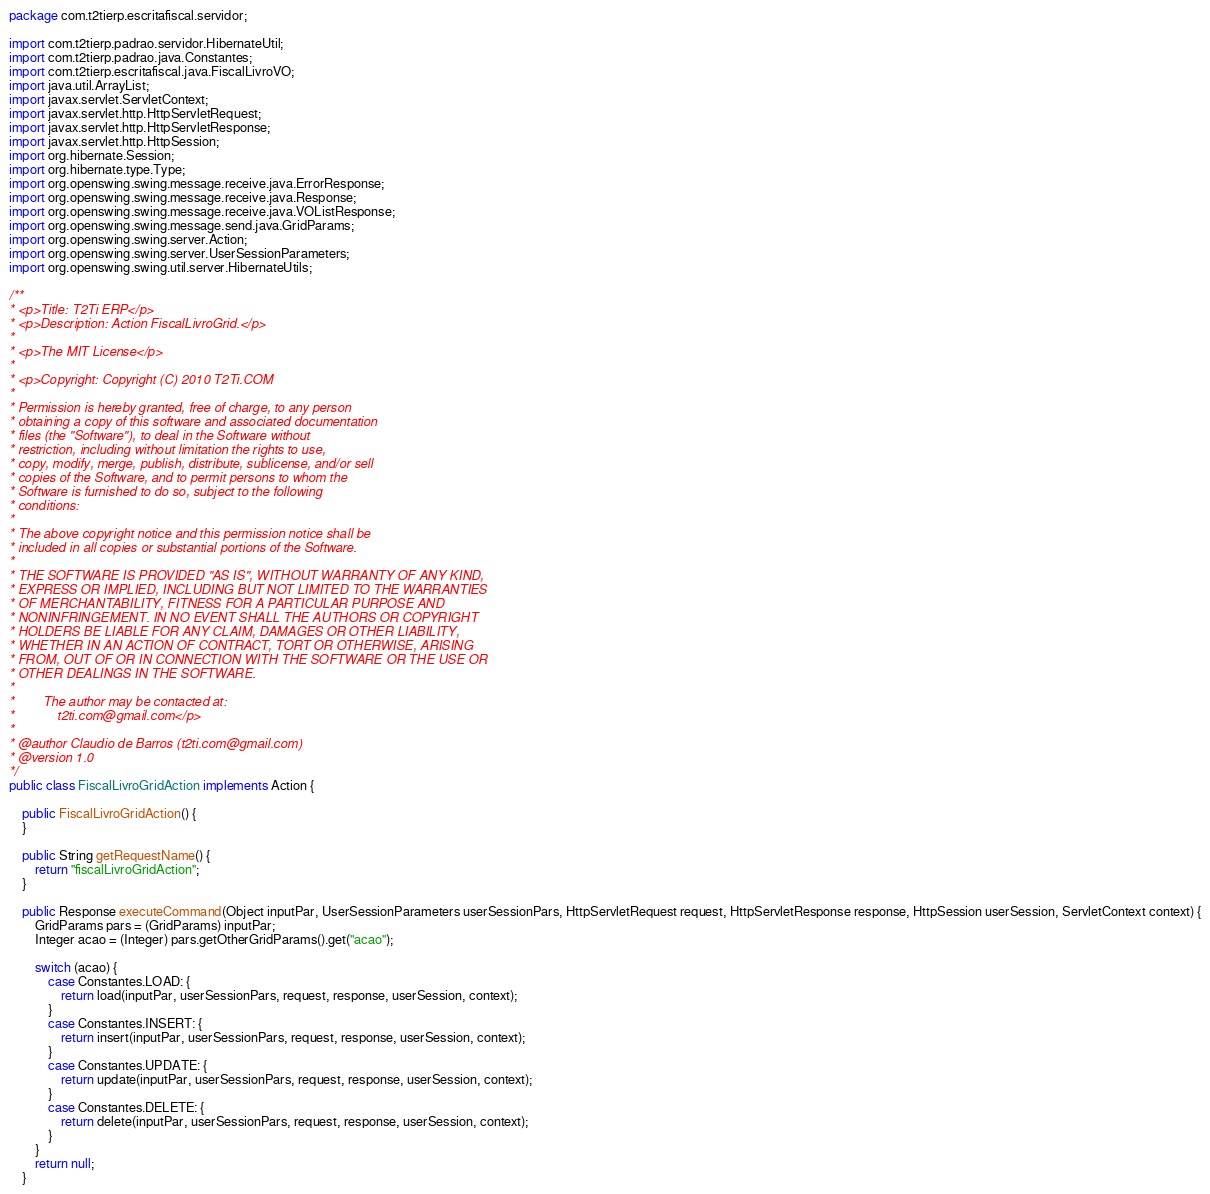<code> <loc_0><loc_0><loc_500><loc_500><_Java_>package com.t2tierp.escritafiscal.servidor;

import com.t2tierp.padrao.servidor.HibernateUtil;
import com.t2tierp.padrao.java.Constantes;
import com.t2tierp.escritafiscal.java.FiscalLivroVO;
import java.util.ArrayList;
import javax.servlet.ServletContext;
import javax.servlet.http.HttpServletRequest;
import javax.servlet.http.HttpServletResponse;
import javax.servlet.http.HttpSession;
import org.hibernate.Session;
import org.hibernate.type.Type;
import org.openswing.swing.message.receive.java.ErrorResponse;
import org.openswing.swing.message.receive.java.Response;
import org.openswing.swing.message.receive.java.VOListResponse;
import org.openswing.swing.message.send.java.GridParams;
import org.openswing.swing.server.Action;
import org.openswing.swing.server.UserSessionParameters;
import org.openswing.swing.util.server.HibernateUtils;

/**
* <p>Title: T2Ti ERP</p>
* <p>Description: Action FiscalLivroGrid.</p>
*
* <p>The MIT License</p>
*
* <p>Copyright: Copyright (C) 2010 T2Ti.COM
*
* Permission is hereby granted, free of charge, to any person
* obtaining a copy of this software and associated documentation
* files (the "Software"), to deal in the Software without
* restriction, including without limitation the rights to use,
* copy, modify, merge, publish, distribute, sublicense, and/or sell
* copies of the Software, and to permit persons to whom the
* Software is furnished to do so, subject to the following
* conditions:
*
* The above copyright notice and this permission notice shall be
* included in all copies or substantial portions of the Software.
*
* THE SOFTWARE IS PROVIDED "AS IS", WITHOUT WARRANTY OF ANY KIND,
* EXPRESS OR IMPLIED, INCLUDING BUT NOT LIMITED TO THE WARRANTIES
* OF MERCHANTABILITY, FITNESS FOR A PARTICULAR PURPOSE AND
* NONINFRINGEMENT. IN NO EVENT SHALL THE AUTHORS OR COPYRIGHT
* HOLDERS BE LIABLE FOR ANY CLAIM, DAMAGES OR OTHER LIABILITY,
* WHETHER IN AN ACTION OF CONTRACT, TORT OR OTHERWISE, ARISING
* FROM, OUT OF OR IN CONNECTION WITH THE SOFTWARE OR THE USE OR
* OTHER DEALINGS IN THE SOFTWARE.
*
*        The author may be contacted at:
*            t2ti.com@gmail.com</p>
*
* @author Claudio de Barros (t2ti.com@gmail.com)
* @version 1.0
*/
public class FiscalLivroGridAction implements Action {

    public FiscalLivroGridAction() {
    }

    public String getRequestName() {
        return "fiscalLivroGridAction";
    }

    public Response executeCommand(Object inputPar, UserSessionParameters userSessionPars, HttpServletRequest request, HttpServletResponse response, HttpSession userSession, ServletContext context) {
        GridParams pars = (GridParams) inputPar;
        Integer acao = (Integer) pars.getOtherGridParams().get("acao");

        switch (acao) {
            case Constantes.LOAD: {
                return load(inputPar, userSessionPars, request, response, userSession, context);
            }
            case Constantes.INSERT: {
                return insert(inputPar, userSessionPars, request, response, userSession, context);
            }
            case Constantes.UPDATE: {
                return update(inputPar, userSessionPars, request, response, userSession, context);
            }
            case Constantes.DELETE: {
                return delete(inputPar, userSessionPars, request, response, userSession, context);
            }
        }
        return null;
    }
</code> 